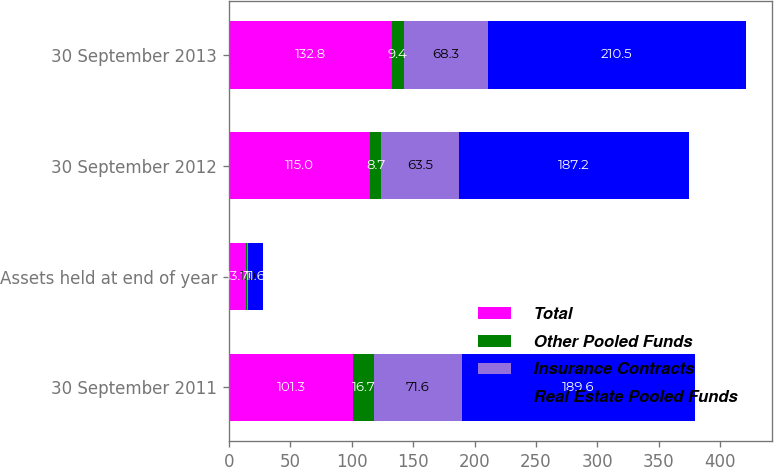Convert chart. <chart><loc_0><loc_0><loc_500><loc_500><stacked_bar_chart><ecel><fcel>30 September 2011<fcel>Assets held at end of year<fcel>30 September 2012<fcel>30 September 2013<nl><fcel>Total<fcel>101.3<fcel>13.7<fcel>115<fcel>132.8<nl><fcel>Other Pooled Funds<fcel>16.7<fcel>1.1<fcel>8.7<fcel>9.4<nl><fcel>Insurance Contracts<fcel>71.6<fcel>1<fcel>63.5<fcel>68.3<nl><fcel>Real Estate Pooled Funds<fcel>189.6<fcel>11.6<fcel>187.2<fcel>210.5<nl></chart> 